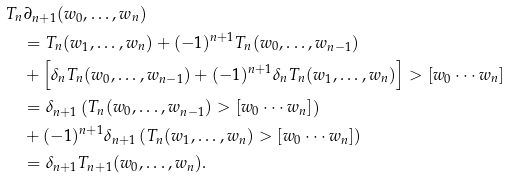Convert formula to latex. <formula><loc_0><loc_0><loc_500><loc_500>& T _ { n } \partial _ { n + 1 } ( w _ { 0 } , \dots , w _ { n } ) \\ & \quad = T _ { n } ( w _ { 1 } , \dots , w _ { n } ) + ( - 1 ) ^ { n + 1 } T _ { n } ( w _ { 0 } , \dots , w _ { n - 1 } ) \\ & \quad + \left [ \delta _ { n } T _ { n } ( w _ { 0 } , \dots , w _ { n - 1 } ) + ( - 1 ) ^ { n + 1 } \delta _ { n } T _ { n } ( w _ { 1 } , \dots , w _ { n } ) \right ] > [ w _ { 0 } \cdots w _ { n } ] \\ & \quad = \delta _ { n + 1 } \left ( T _ { n } ( w _ { 0 } , \dots , w _ { n - 1 } ) > [ w _ { 0 } \cdots w _ { n } ] \right ) \\ & \quad + ( - 1 ) ^ { n + 1 } \delta _ { n + 1 } \left ( T _ { n } ( w _ { 1 } , \dots , w _ { n } ) > [ w _ { 0 } \cdots w _ { n } ] \right ) \\ & \quad = \delta _ { n + 1 } T _ { n + 1 } ( w _ { 0 } , \dots , w _ { n } ) .</formula> 